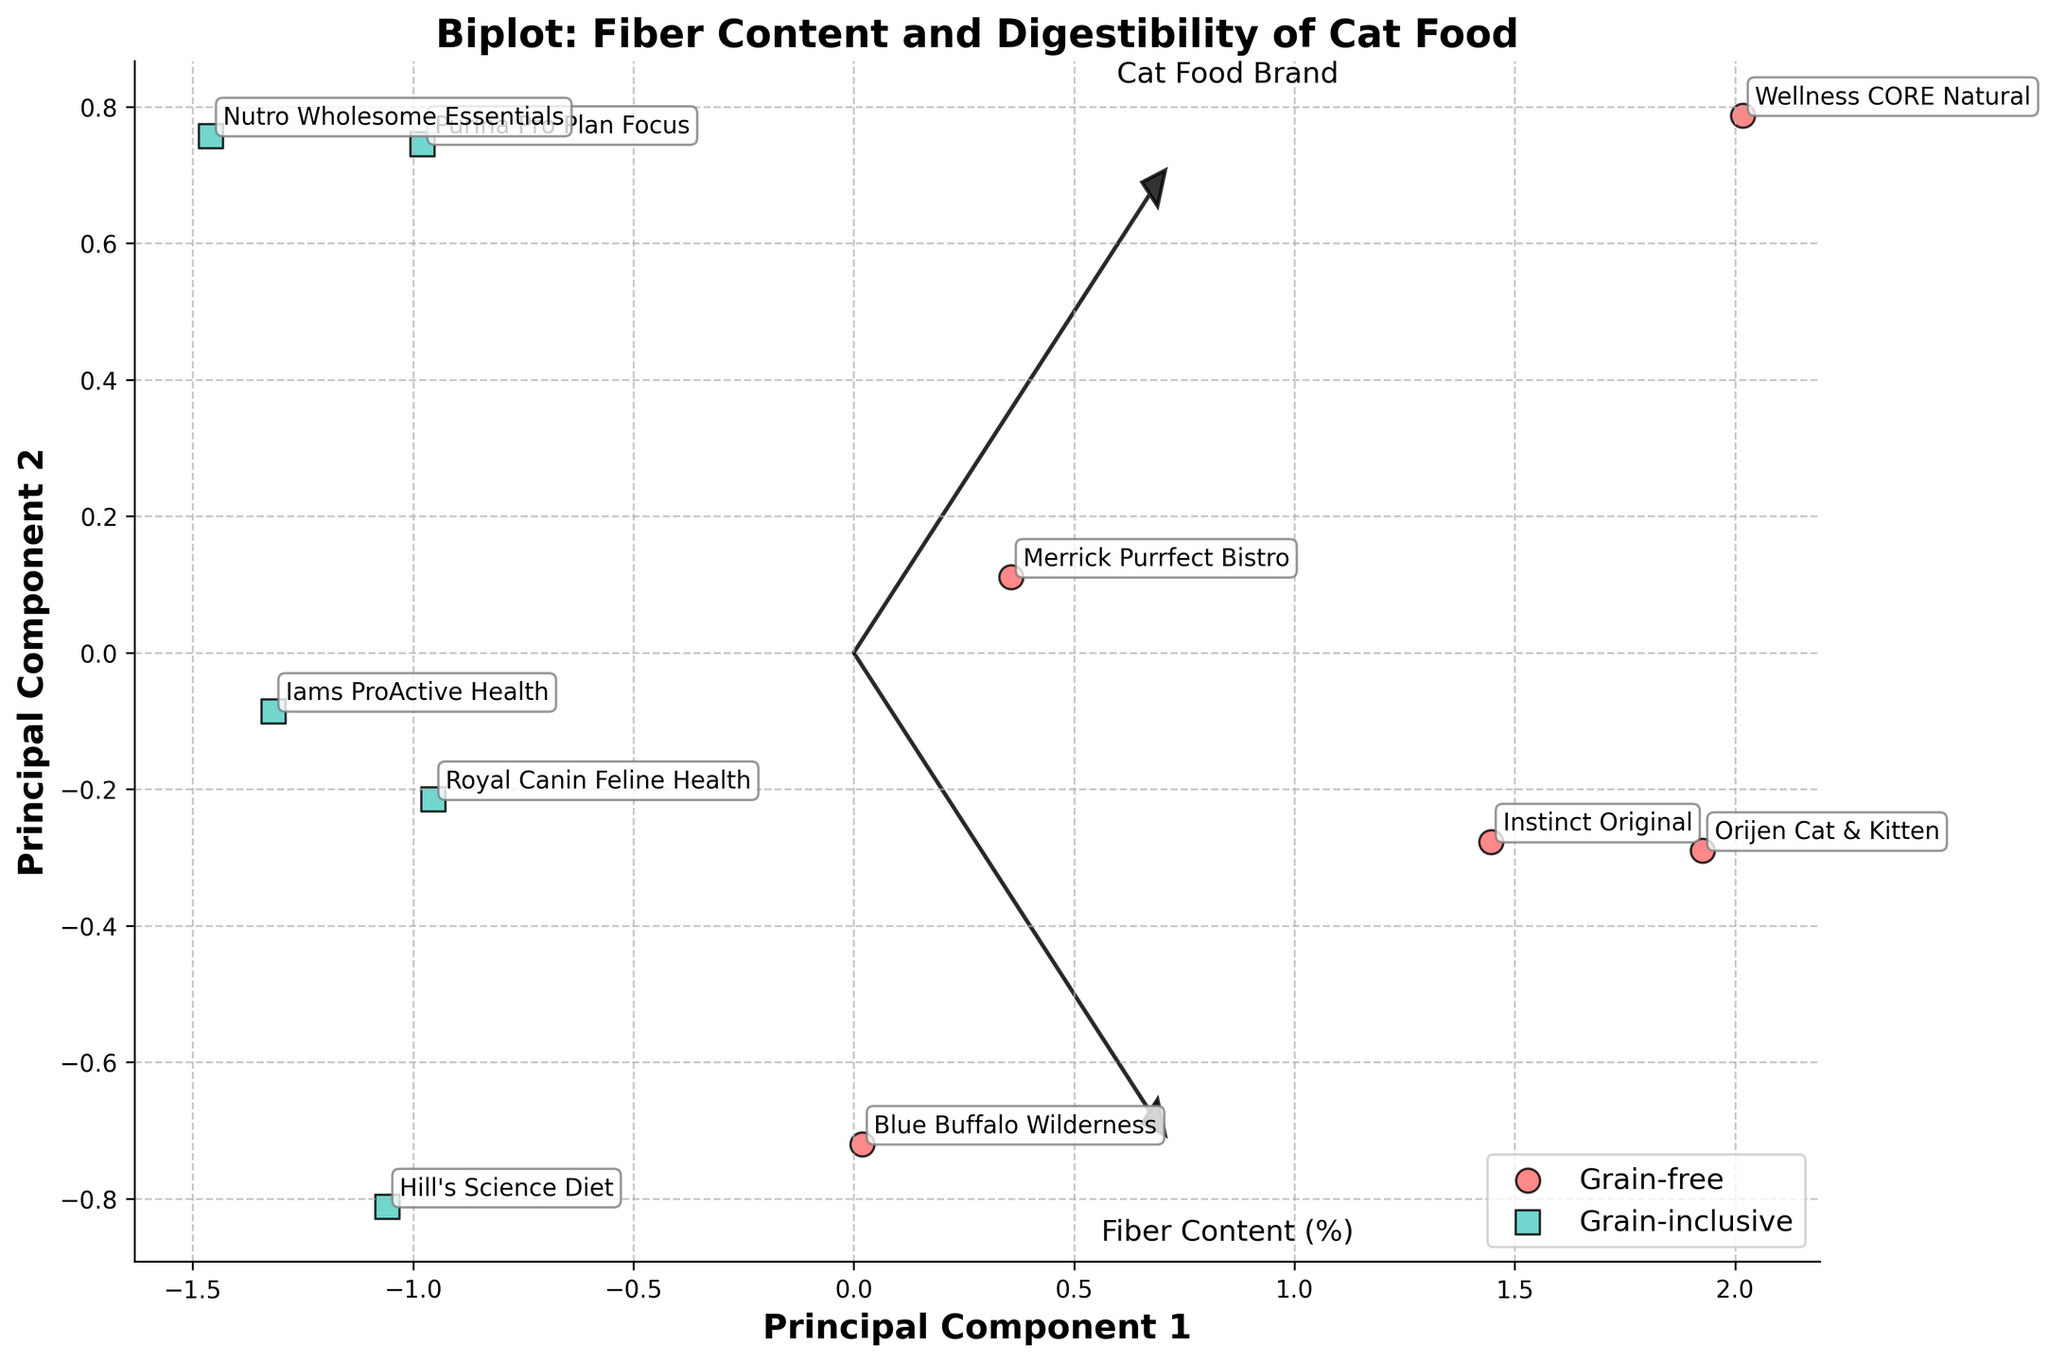What is the title of the biplot? The title is located at the top of the plot and is usually in a larger and bold font.
Answer: Biplot: Fiber Content and Digestibility of Cat Food How many principal components are displayed in the biplot? The biplot shows two main axes labeled as Principal Component 1 and Principal Component 2.
Answer: 2 Which cat food brand has the highest Digestibility Score among the grain-free options? To find this, look for the grain-free data points (circles) and identify the one with the highest vertical position in dimensions of the principal components.
Answer: Orijen Cat & Kitten How many brands are categorized as grain-free? Count the number of data points represented by circles in the plot.
Answer: 5 What does the arrow pointing from the origin indicate? Arrows represent feature vectors of each original feature, indicating the direction and magnitude of each feature (Fiber Content and Digestibility Score).
Answer: Feature vectors What is the relationship between grain-free and grain-inclusive formulas concerning Fiber Content and Digestibility Score in the first principal component? Check the alignment of the two groups' data points with respect to the first principal component axis.
Answer: Grain-free formulas have higher values on the first principal component Are there more brands with a higher Fiber Content (%) or higher Digestibility Score? Assess the length and direction of the respective feature vectors to determine which feature contributes more to the principal components.
Answer: Both contribute similarly based on the plot 